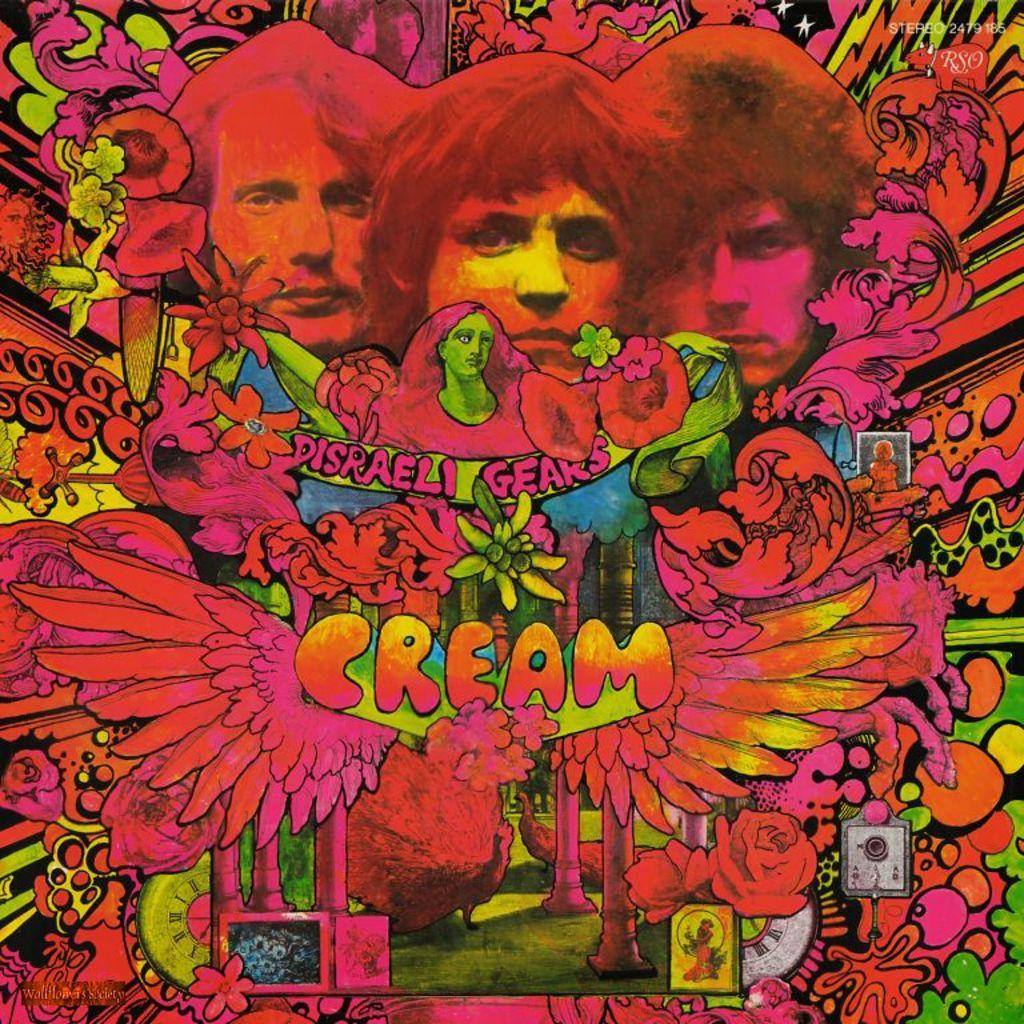<image>
Present a compact description of the photo's key features. Psychodelic poster for "Disraeli Gears" and says Cream. 